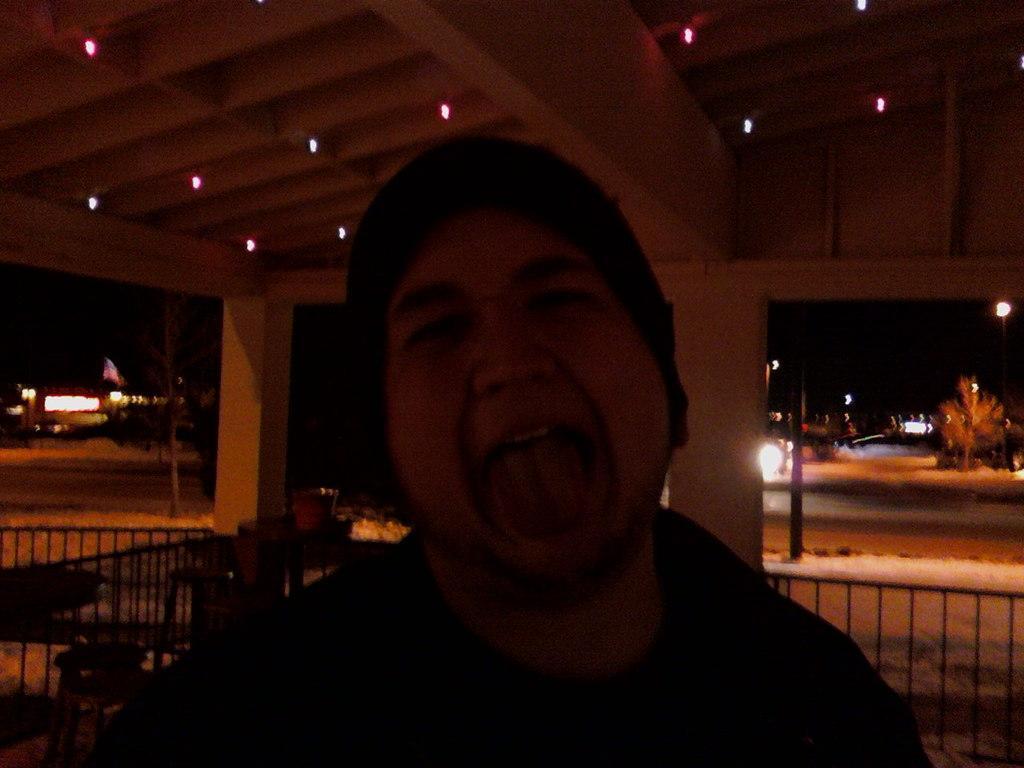Describe this image in one or two sentences. In this picture, we can see a person, and in the background we can see pillars, roof with lights, ground, trees, plants, fencing, a few vehicles, poles, lights, and the dark sky. 